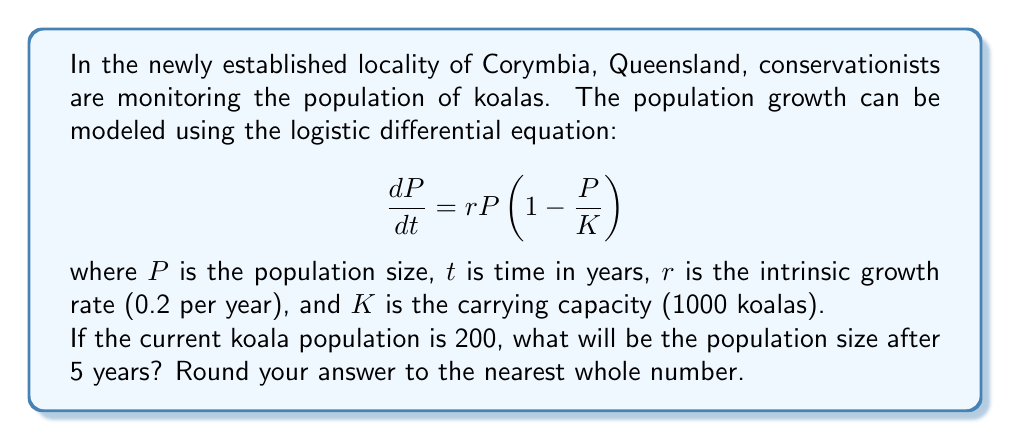Help me with this question. To solve this problem, we need to use the solution to the logistic differential equation:

$$P(t) = \frac{K}{1 + (\frac{K}{P_0} - 1)e^{-rt}}$$

Where:
$K = 1000$ (carrying capacity)
$P_0 = 200$ (initial population)
$r = 0.2$ (intrinsic growth rate)
$t = 5$ (time in years)

Let's substitute these values into the equation:

$$P(5) = \frac{1000}{1 + (\frac{1000}{200} - 1)e^{-0.2(5)}}$$

$$P(5) = \frac{1000}{1 + (5 - 1)e^{-1}}$$

$$P(5) = \frac{1000}{1 + 4e^{-1}}$$

Now, let's calculate this step by step:

1. Calculate $e^{-1} \approx 0.3679$
2. Multiply: $4 * 0.3679 = 1.4716$
3. Add 1: $1 + 1.4716 = 2.4716$
4. Divide: $1000 / 2.4716 \approx 404.5977$

Rounding to the nearest whole number, we get 405.
Answer: 405 koalas 